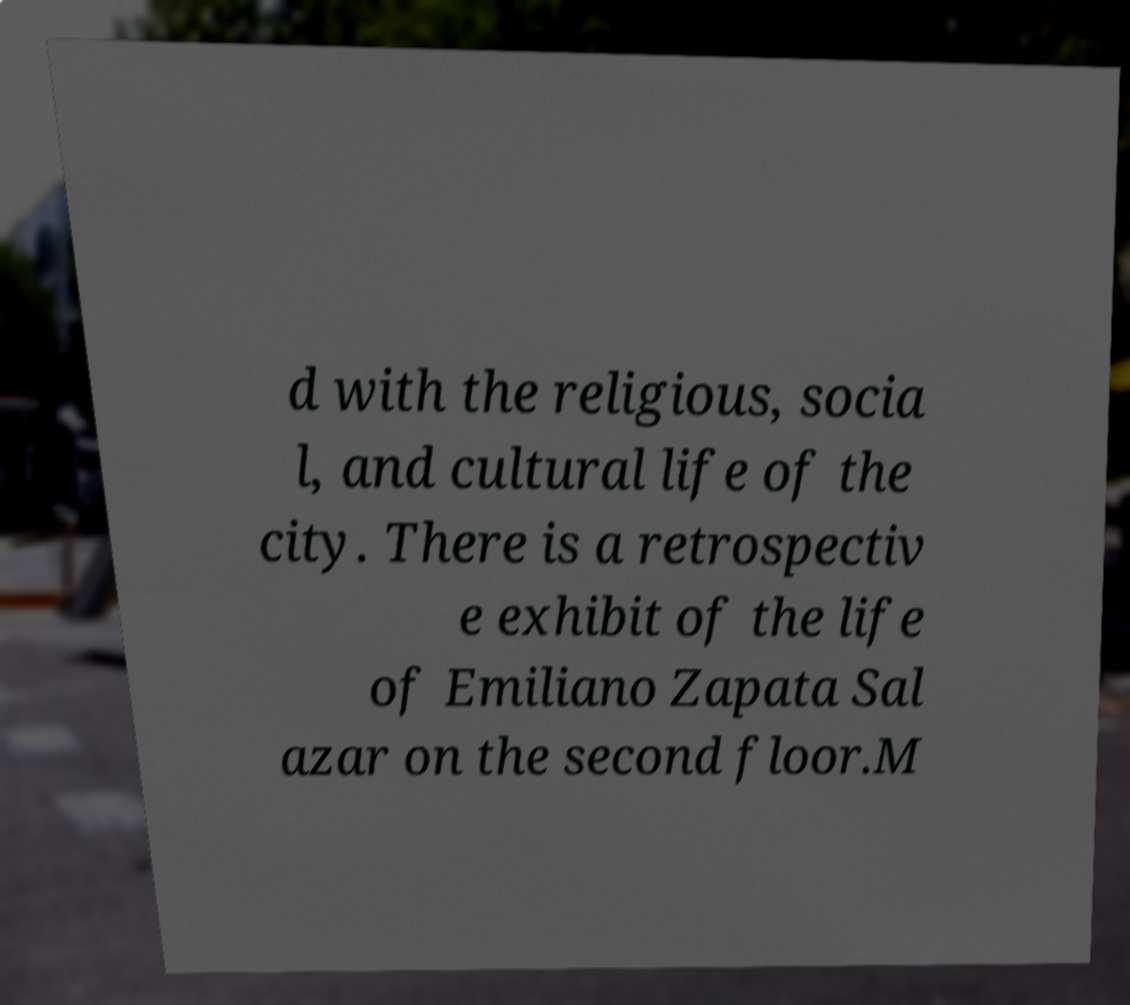Please identify and transcribe the text found in this image. d with the religious, socia l, and cultural life of the city. There is a retrospectiv e exhibit of the life of Emiliano Zapata Sal azar on the second floor.M 